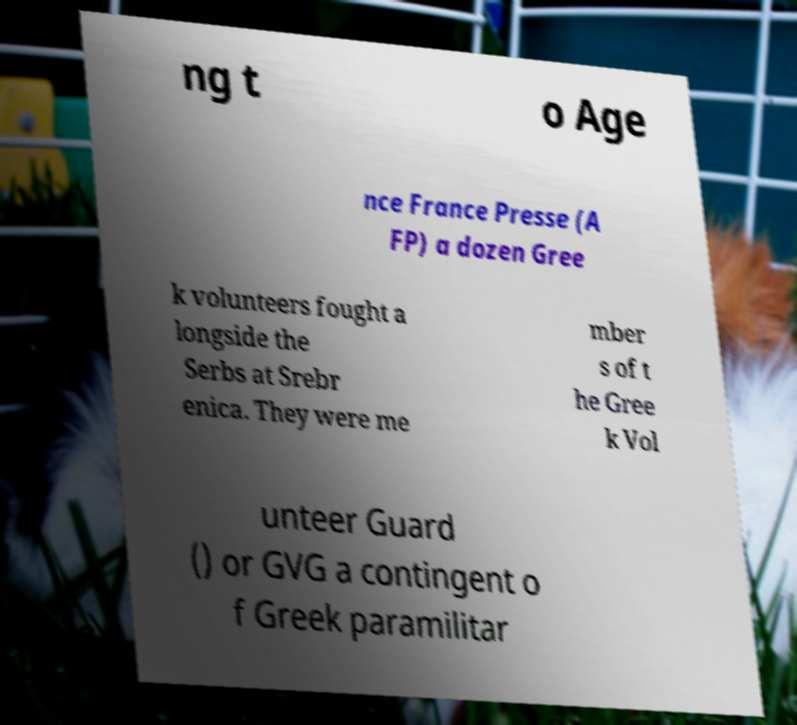Can you accurately transcribe the text from the provided image for me? ng t o Age nce France Presse (A FP) a dozen Gree k volunteers fought a longside the Serbs at Srebr enica. They were me mber s of t he Gree k Vol unteer Guard () or GVG a contingent o f Greek paramilitar 